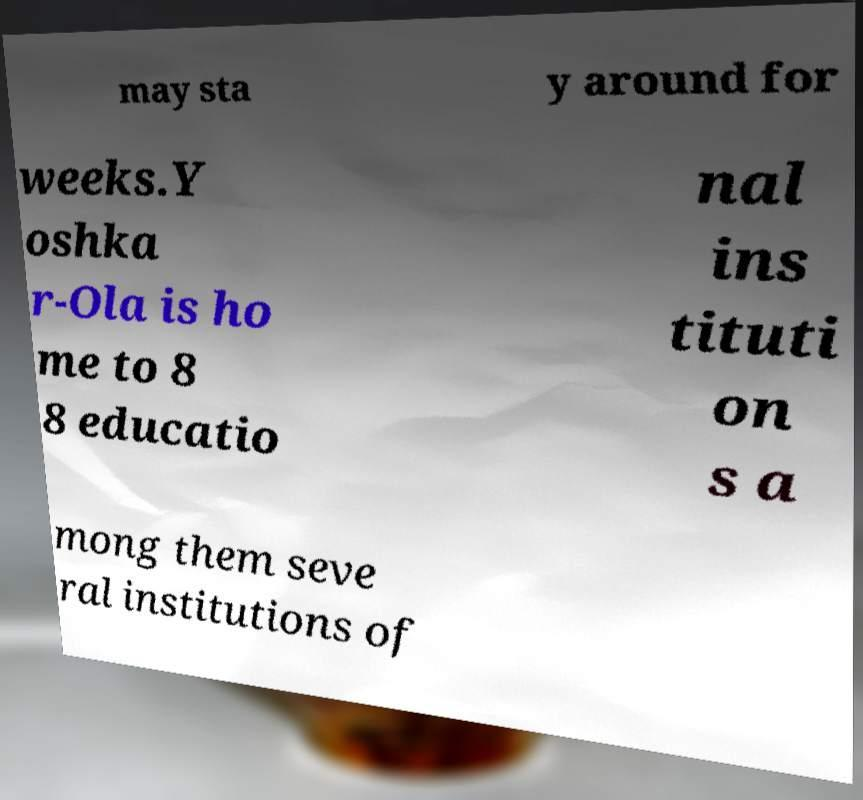Could you assist in decoding the text presented in this image and type it out clearly? may sta y around for weeks.Y oshka r-Ola is ho me to 8 8 educatio nal ins tituti on s a mong them seve ral institutions of 